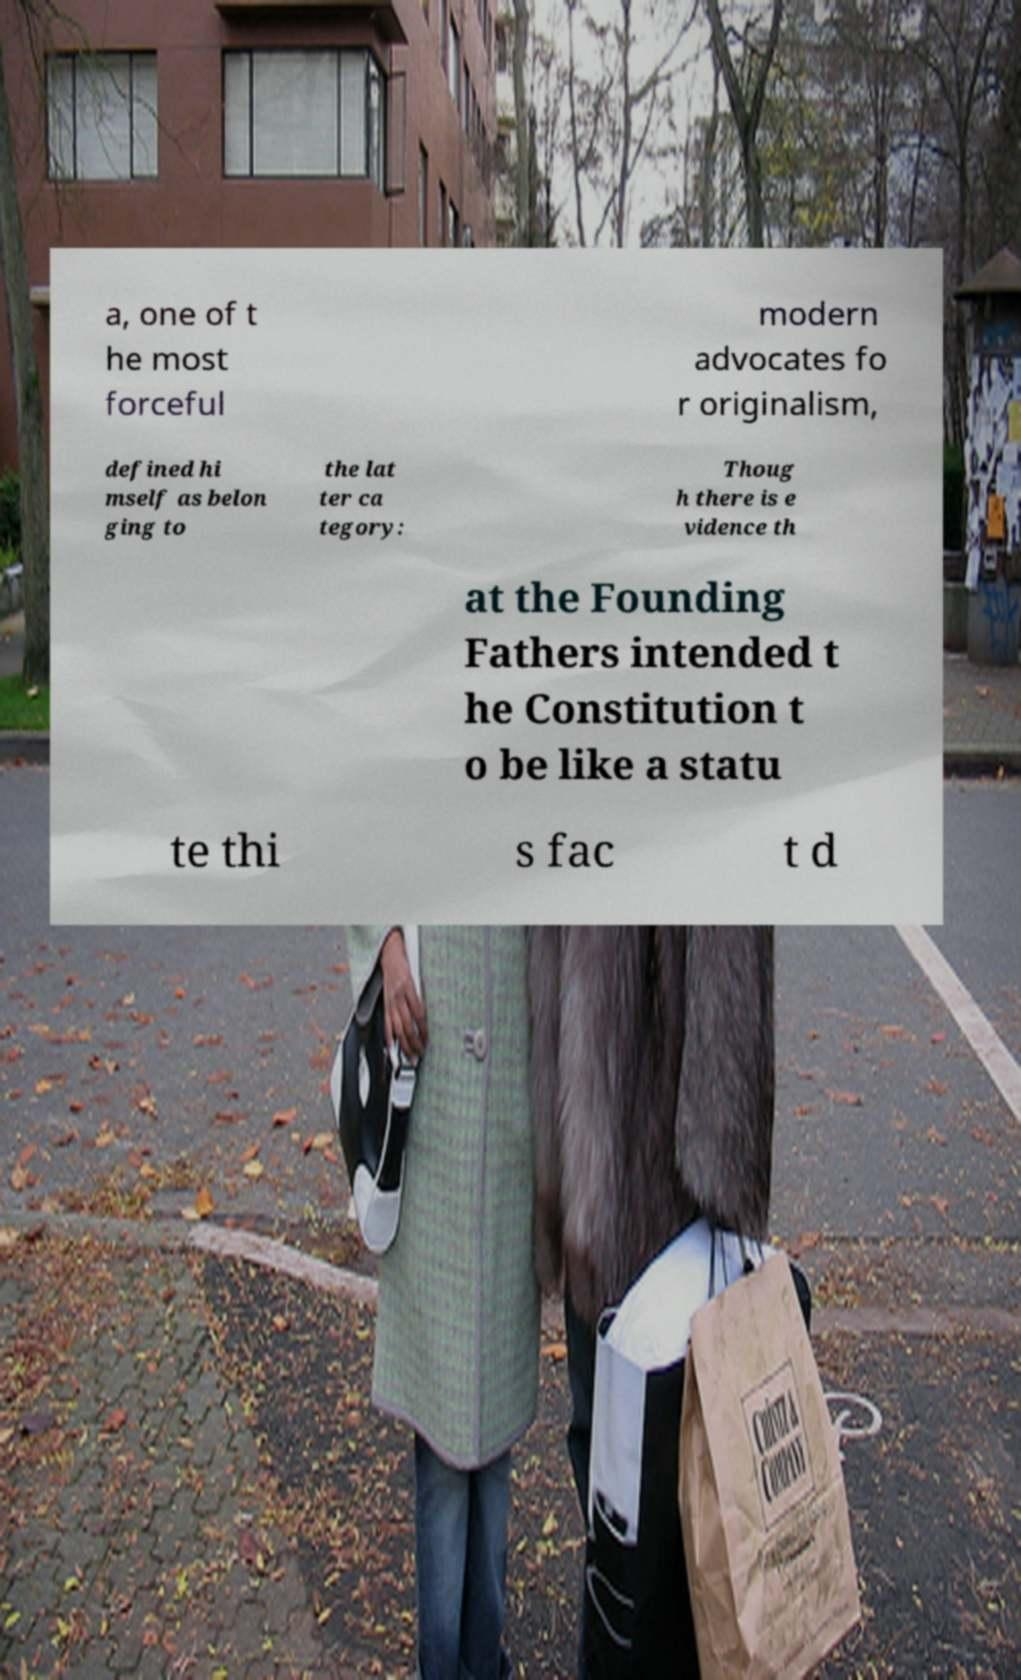Could you extract and type out the text from this image? a, one of t he most forceful modern advocates fo r originalism, defined hi mself as belon ging to the lat ter ca tegory: Thoug h there is e vidence th at the Founding Fathers intended t he Constitution t o be like a statu te thi s fac t d 